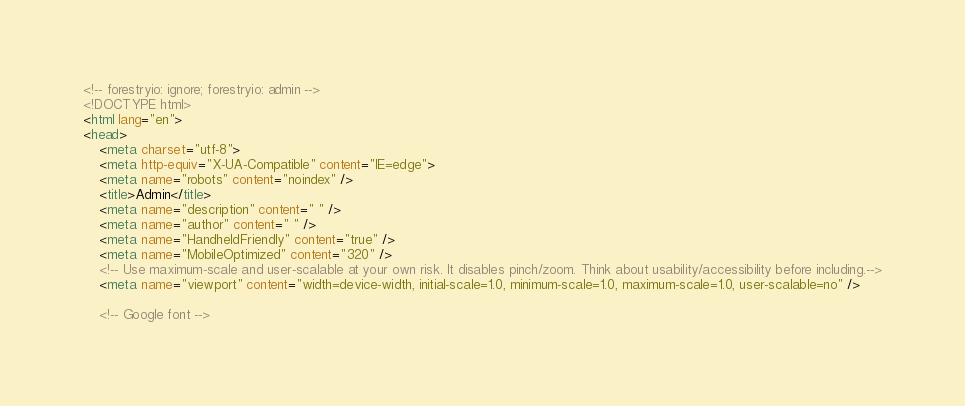<code> <loc_0><loc_0><loc_500><loc_500><_HTML_><!-- forestryio: ignore; forestryio: admin -->
<!DOCTYPE html>
<html lang="en">
<head>
    <meta charset="utf-8">
    <meta http-equiv="X-UA-Compatible" content="IE=edge">
    <meta name="robots" content="noindex" />
    <title>Admin</title>
    <meta name="description" content=" " />
    <meta name="author" content=" " />
    <meta name="HandheldFriendly" content="true" />
    <meta name="MobileOptimized" content="320" />
    <!-- Use maximum-scale and user-scalable at your own risk. It disables pinch/zoom. Think about usability/accessibility before including.-->
    <meta name="viewport" content="width=device-width, initial-scale=1.0, minimum-scale=1.0, maximum-scale=1.0, user-scalable=no" />

    <!-- Google font --></code> 